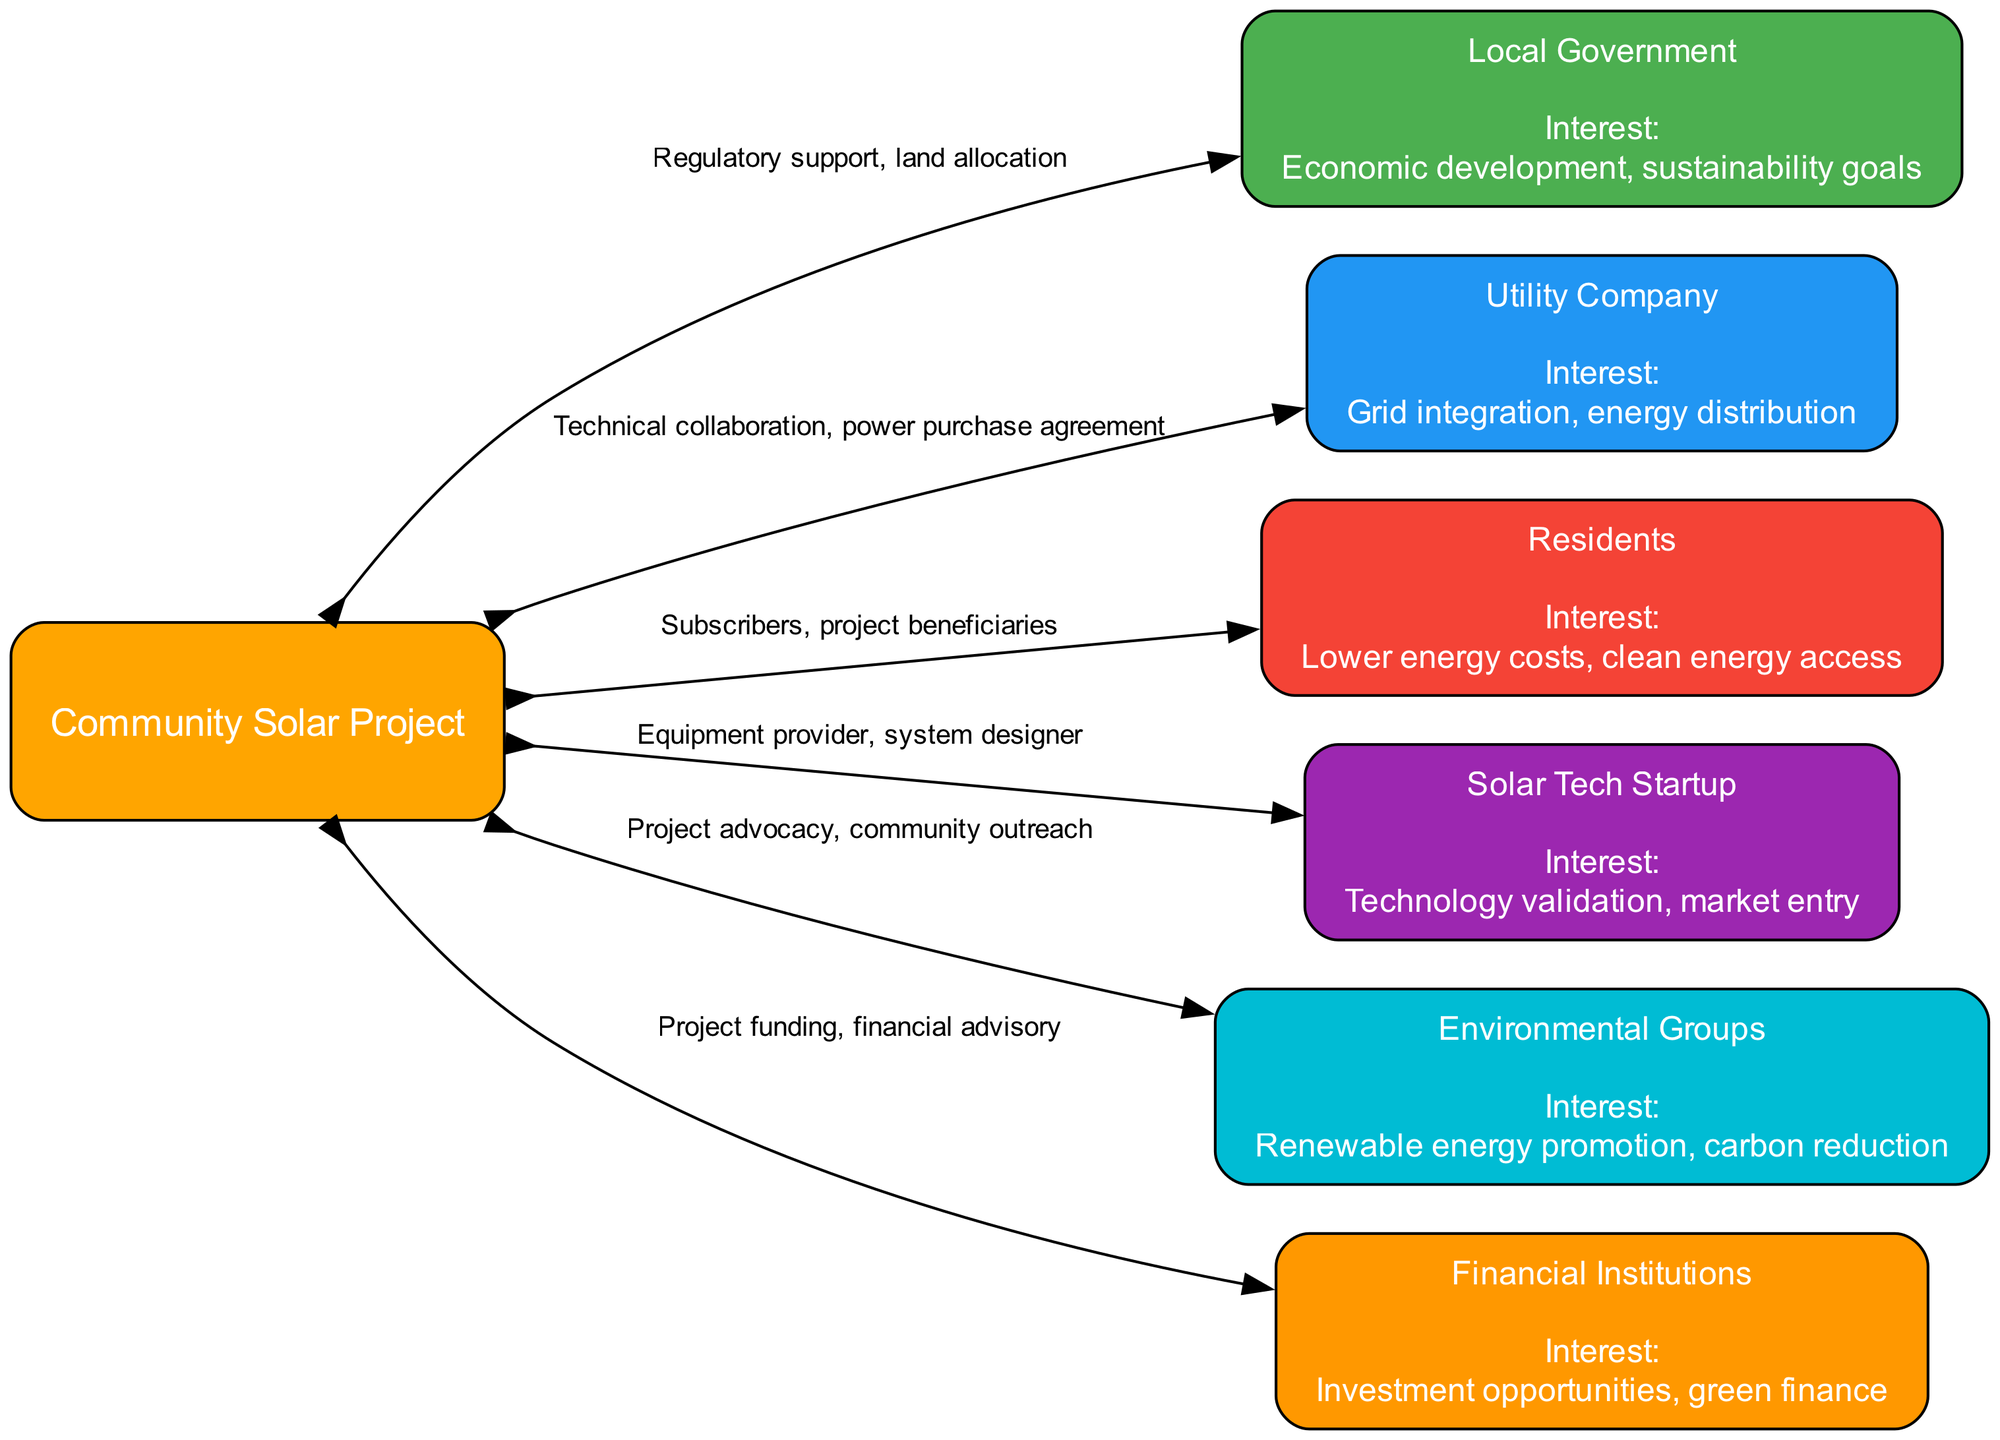What is the central node of the diagram? The central node is labeled "Community Solar Project," which is the focal point of the diagram around which all stakeholders are oriented.
Answer: Community Solar Project How many stakeholders are represented in the diagram? The diagram lists 6 stakeholders, each with specified interests and relationships to the central node.
Answer: 6 What is the interest of the Local Government? The interest of the Local Government is listed as "Economic development, sustainability goals," which summarizes their focus areas regarding the project.
Answer: Economic development, sustainability goals What relationship does the Utility Company have with the Community Solar Project? The Utility Company has a relationship described as "Technical collaboration, power purchase agreement," showing how they interact with the project.
Answer: Technical collaboration, power purchase agreement Which stakeholder has an interest in "Investment opportunities, green finance"? The stakeholder interested in "Investment opportunities, green finance" is the "Financial Institutions," which indicates their focus on funding aspects of the project.
Answer: Financial Institutions Which two stakeholders are primarily focused on environmental concerns? The stakeholders focused on environmental concerns are "Environmental Groups" and "Residents," with the former advocating for renewable energy and the latter benefitting from clean energy access.
Answer: Environmental Groups, Residents Which stakeholder is involved in the equipment provision for the project? The stakeholder involved in equipment provision is the "Solar Tech Startup," which plays a crucial role in supplying the technology needed for the solar project.
Answer: Solar Tech Startup What is the relationship between Residents and the Community Solar Project? The relationship is defined as "Subscribers, project beneficiaries," highlighting how local residents participate and benefit from the solar initiative.
Answer: Subscribers, project beneficiaries What color represents the Environmental Groups in the diagram? The Environmental Groups are represented in purple color, specifically using the hex code associated with that color as per the diagram's node styling.
Answer: Purple 